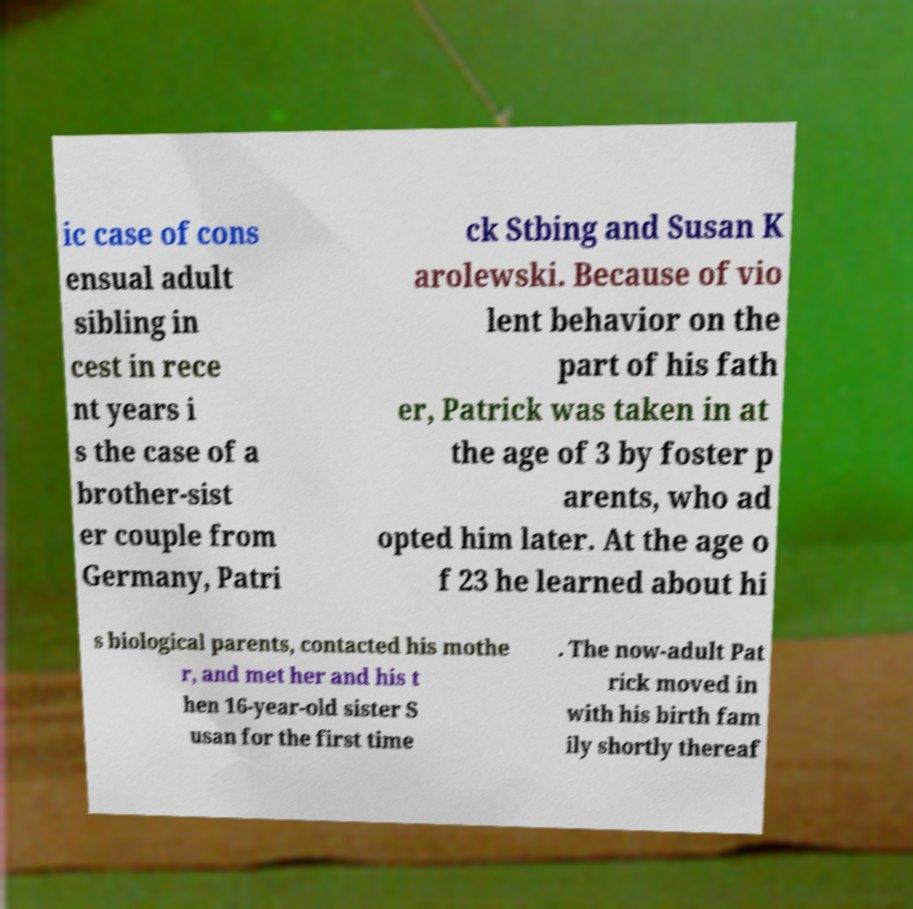What messages or text are displayed in this image? I need them in a readable, typed format. ic case of cons ensual adult sibling in cest in rece nt years i s the case of a brother-sist er couple from Germany, Patri ck Stbing and Susan K arolewski. Because of vio lent behavior on the part of his fath er, Patrick was taken in at the age of 3 by foster p arents, who ad opted him later. At the age o f 23 he learned about hi s biological parents, contacted his mothe r, and met her and his t hen 16-year-old sister S usan for the first time . The now-adult Pat rick moved in with his birth fam ily shortly thereaf 